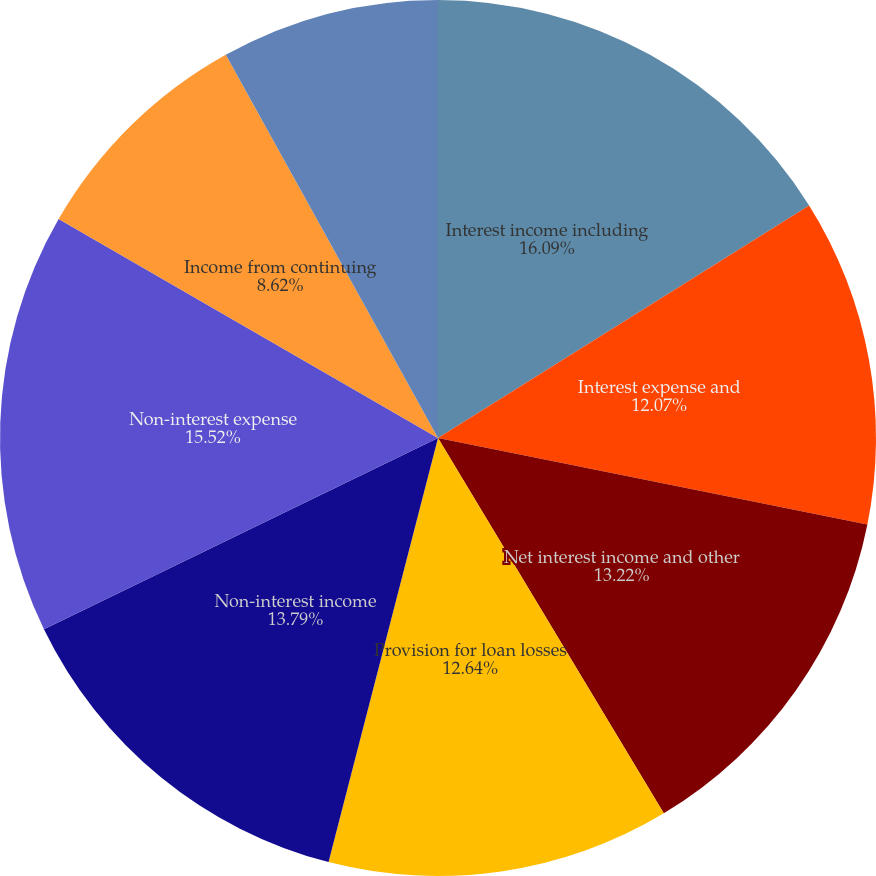Convert chart. <chart><loc_0><loc_0><loc_500><loc_500><pie_chart><fcel>Interest income including<fcel>Interest expense and<fcel>Net interest income and other<fcel>Provision for loan losses<fcel>Non-interest income<fcel>Non-interest expense<fcel>Income from continuing<fcel>Income tax expense<nl><fcel>16.09%<fcel>12.07%<fcel>13.22%<fcel>12.64%<fcel>13.79%<fcel>15.52%<fcel>8.62%<fcel>8.05%<nl></chart> 